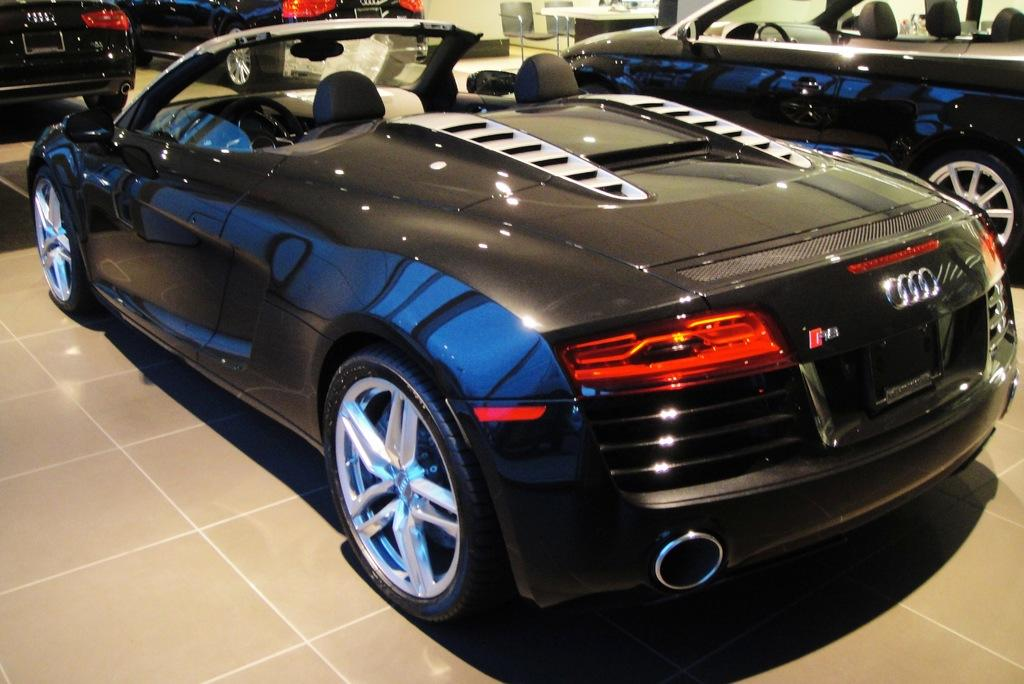What type of vehicles are present in the image? There are Audi cars in the image. What type of conversation are the Audi cars having in the image? Cars do not have the ability to talk or have conversations, so there is no conversation between the Audi cars in the image. 